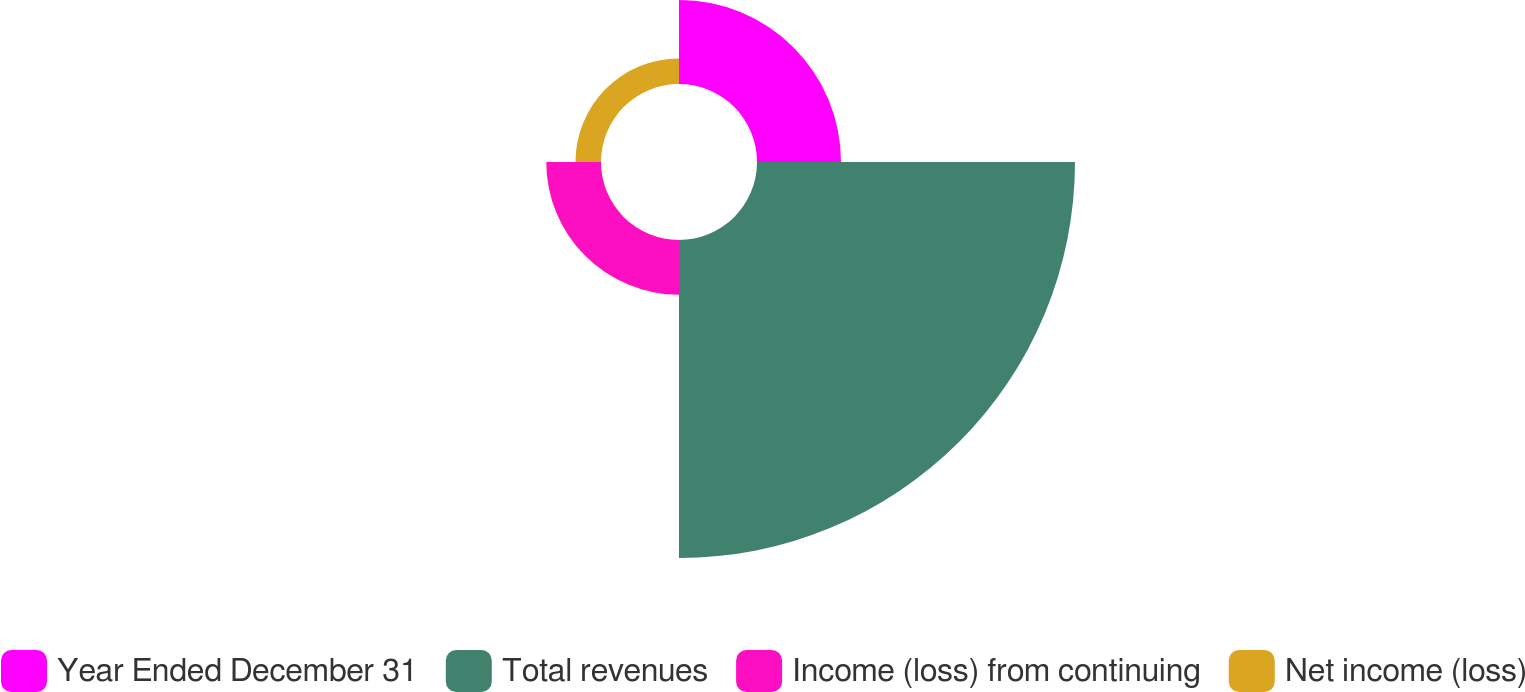Convert chart. <chart><loc_0><loc_0><loc_500><loc_500><pie_chart><fcel>Year Ended December 31<fcel>Total revenues<fcel>Income (loss) from continuing<fcel>Net income (loss)<nl><fcel>17.42%<fcel>65.95%<fcel>11.35%<fcel>5.29%<nl></chart> 